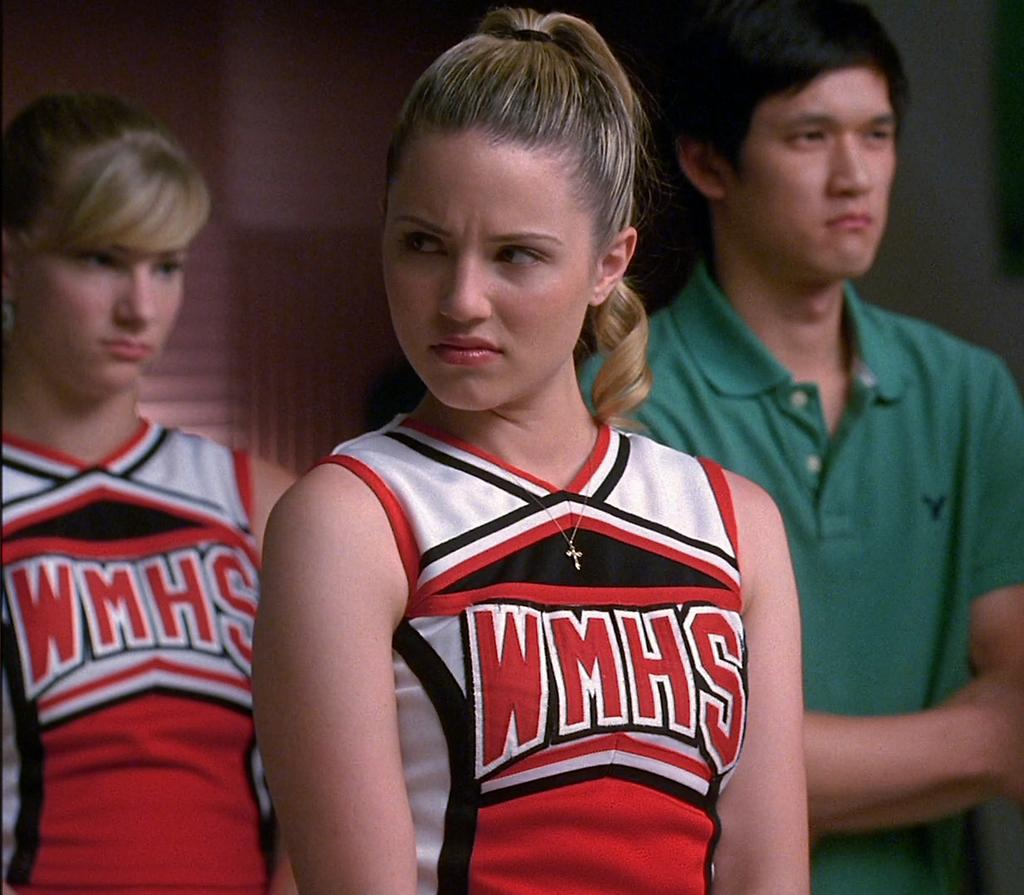<image>
Relay a brief, clear account of the picture shown. Cheerleader wearing a top that says WMHS on it. 